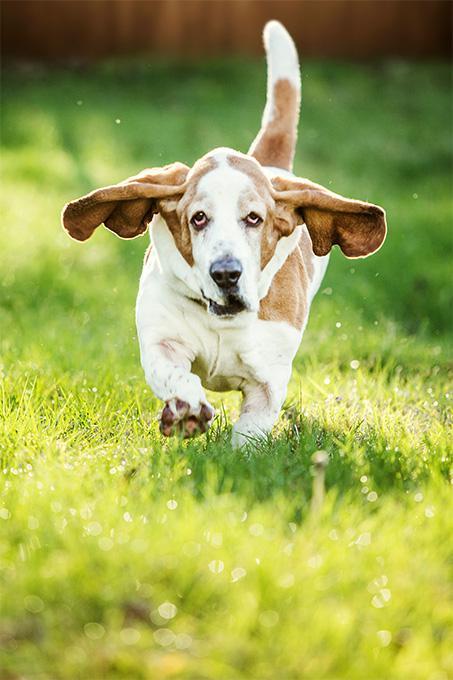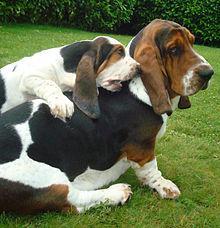The first image is the image on the left, the second image is the image on the right. Given the left and right images, does the statement "There are two dogs in the image pair." hold true? Answer yes or no. No. The first image is the image on the left, the second image is the image on the right. Analyze the images presented: Is the assertion "A hound dog is running forward on the green grass." valid? Answer yes or no. Yes. 